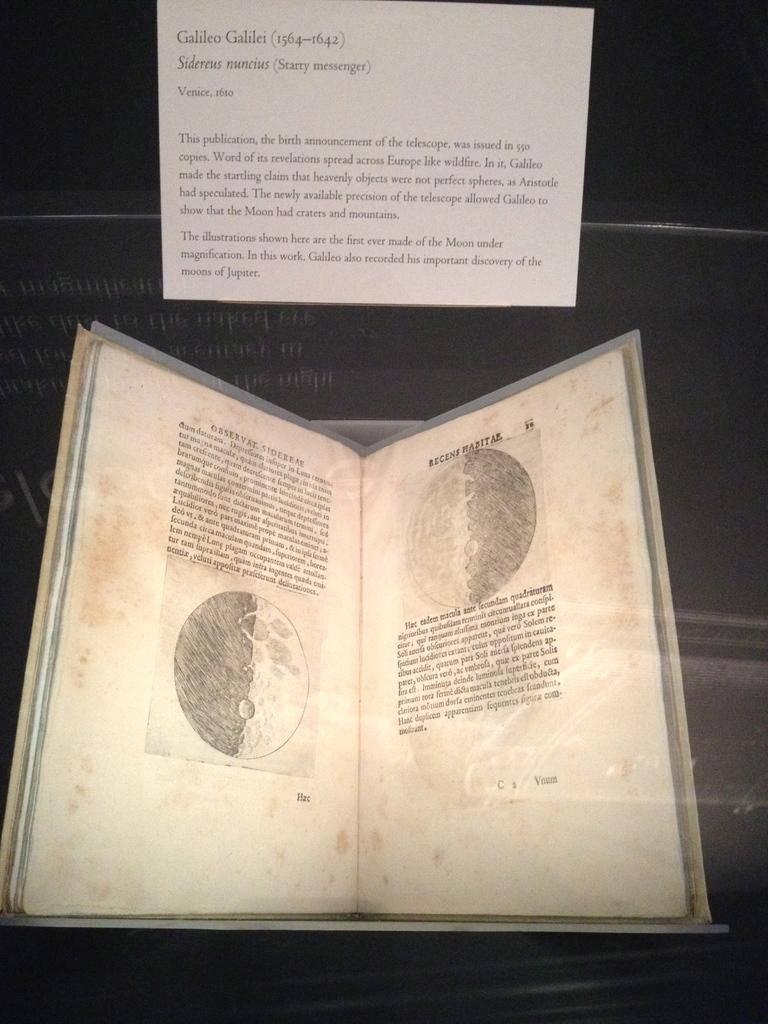Provide a one-sentence caption for the provided image. Book about Galileo that includes pictures and details. 